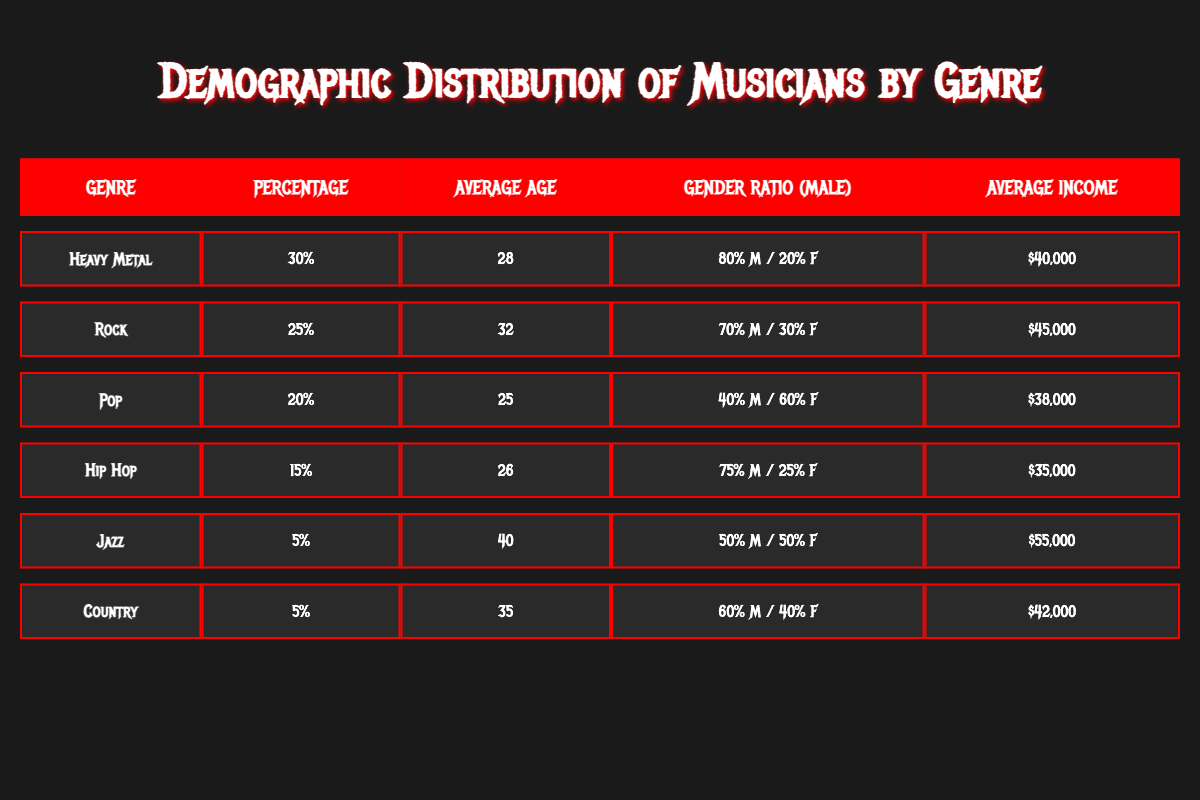What percentage of musicians prefer Heavy Metal? The table states that the percentage of musicians who prefer Heavy Metal is displayed directly in the percentage column for that genre. The value is 30.
Answer: 30 What is the average age of musicians who enjoy Pop music? Referring to the table, the average age is found in the row corresponding to the Pop genre. The value in that row is 25.
Answer: 25 Is the average income of Rock musicians higher than that of Country musicians? Comparing the average income from the Rock and Country rows, Rock has an average income of 45,000 and Country has 42,000. Since 45,000 is greater than 42,000, the answer is yes.
Answer: Yes What is the gender ratio of Jazz musicians? The gender ratio for Jazz musicians is given in the table, which indicates that there is a 50% male and 50% female split. This is taken from the respective column for Jazz.
Answer: 50% male, 50% female What is the average income of musicians who play Hip Hop and Pop combined? To find the average income of Hip Hop and Pop musicians, we first note the incomes: Hip Hop is 35,000 and Pop is 38,000. The sum is (35,000 + 38,000) = 73,000. Then, we divide by 2 to find the average: 73,000 / 2 = 36,500.
Answer: 36,500 What genre has the highest percentage of musicians? By scanning the percentage column, Heavy Metal has the highest value of 30, compared to all other genres listed.
Answer: Heavy Metal Is the average age of musicians who prefer Heavy Metal lower than that of Jazz musicians? The average age for Heavy Metal is 28, and for Jazz, it’s 40. Since 28 is less than 40, the answer is yes.
Answer: Yes What is the total percentage of musicians who play Rock and Hip Hop? To find the total percentage, we sum the two percentages: Rock is 25 and Hip Hop is 15. So, 25 + 15 = 40 percent.
Answer: 40 How many more years on average do Country musicians have compared to Heavy Metal musicians? The average age for Country musicians is 35, and for Heavy Metal musicians it's 28. To find the difference, we subtract: 35 - 28 = 7 years.
Answer: 7 years 